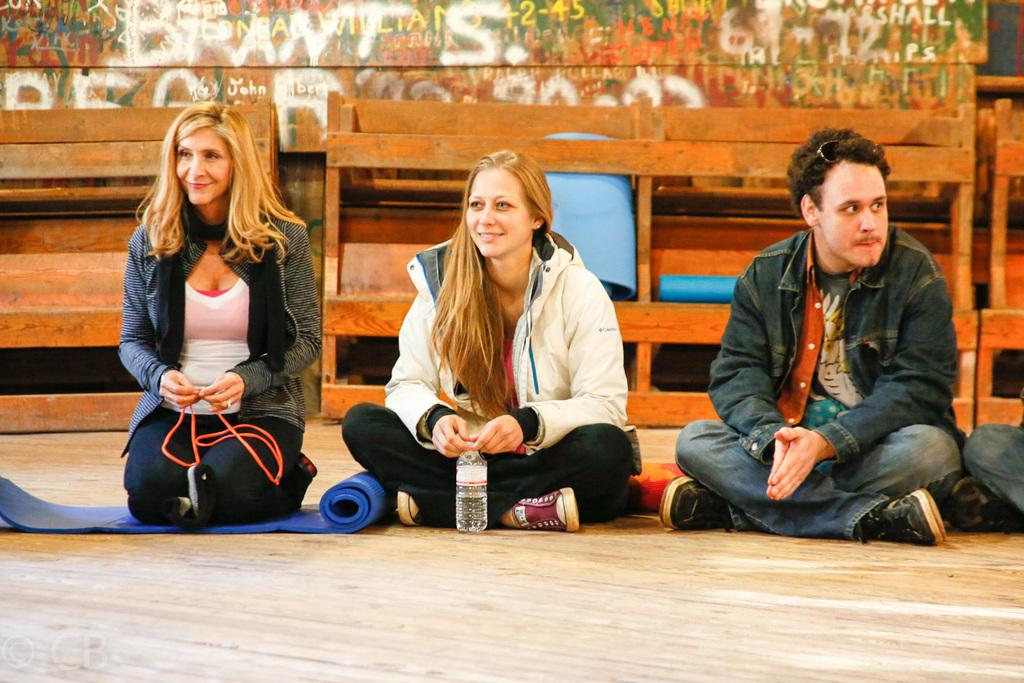How many people are in the image? There are three people in the image. Can you describe the position of each person? One person is sitting on the left side, one person is sitting in the middle, and one person is sitting on the right side. What type of baseball equipment can be seen in the image? There is no baseball equipment present in the image. Can you describe the toothbrush used by one of the people in the image? There is no toothbrush present in the image. 